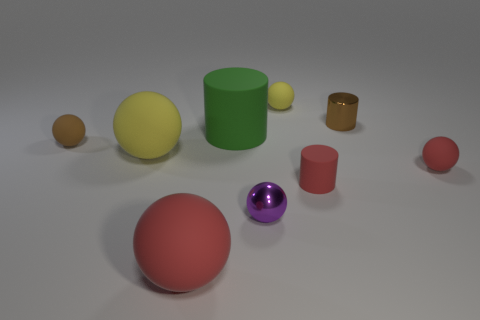Subtract all small red cylinders. How many cylinders are left? 2 Subtract all yellow spheres. How many spheres are left? 4 Subtract all balls. How many objects are left? 3 Subtract 2 spheres. How many spheres are left? 4 Subtract all yellow cylinders. Subtract all green spheres. How many cylinders are left? 3 Subtract all purple spheres. How many green cylinders are left? 1 Subtract all shiny balls. Subtract all large red things. How many objects are left? 7 Add 7 tiny matte balls. How many tiny matte balls are left? 10 Add 3 large green rubber cylinders. How many large green rubber cylinders exist? 4 Subtract 0 red blocks. How many objects are left? 9 